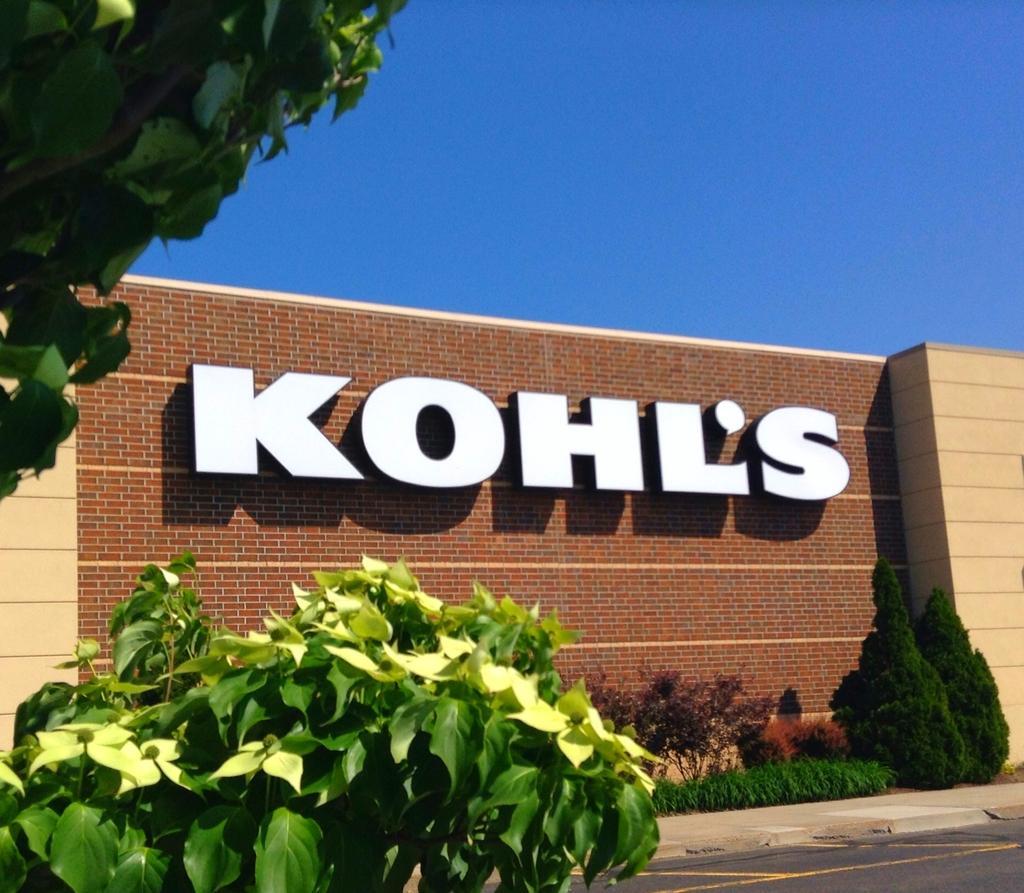Describe this image in one or two sentences. In this picture I can see text on the wall and I can see plants, trees and a blue sky. 